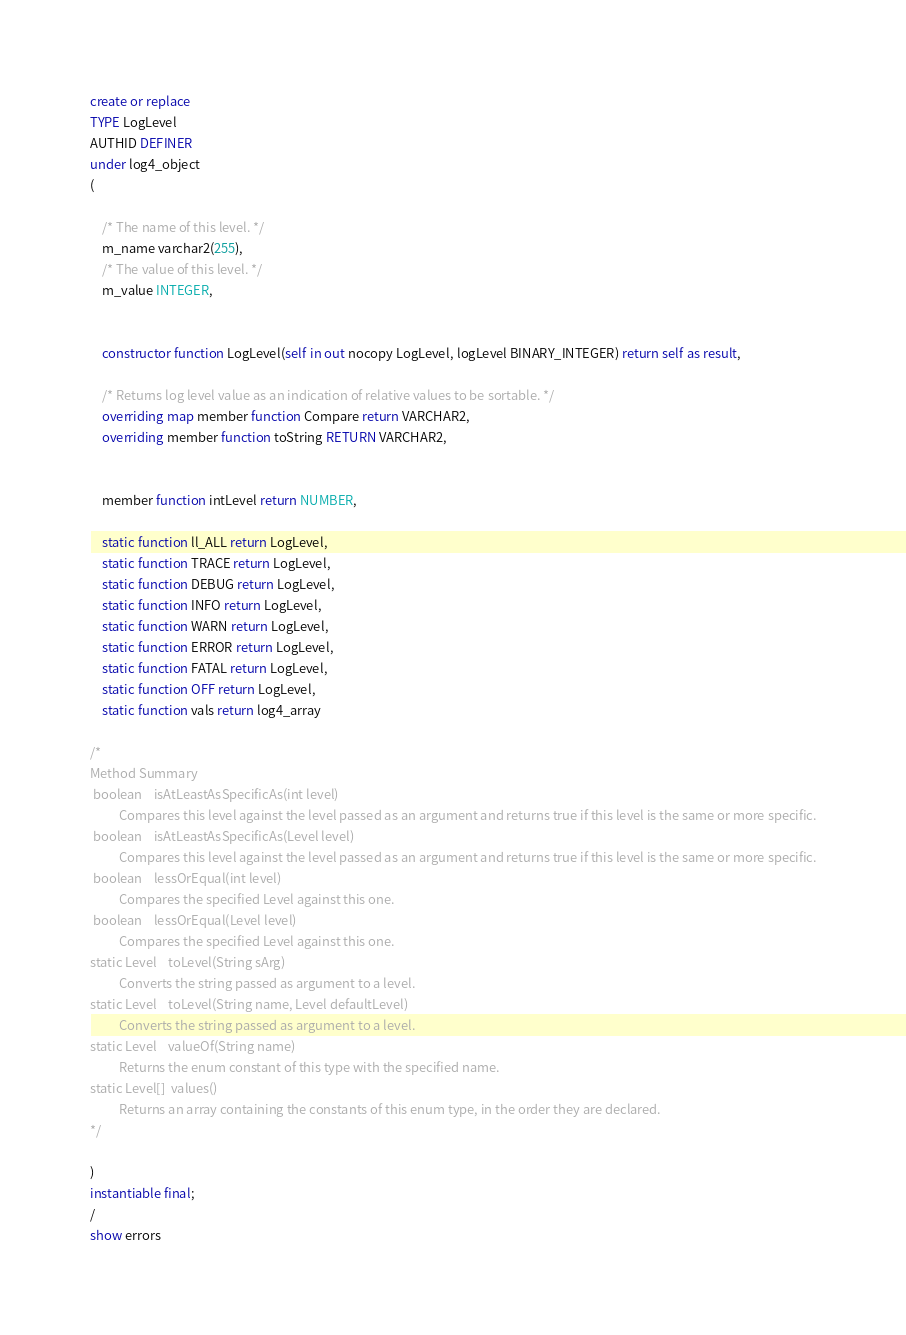<code> <loc_0><loc_0><loc_500><loc_500><_SQL_>create or replace
TYPE LogLevel 
AUTHID DEFINER
under log4_object
(

	/* The name of this level. */
	m_name varchar2(255),
	/* The value of this level. */
	m_value INTEGER,

	
	constructor function LogLevel(self in out nocopy LogLevel, logLevel BINARY_INTEGER) return self as result,

	/* Returns log level value as an indication of relative values to be sortable. */
	overriding map member function Compare return VARCHAR2,
	overriding member function toString RETURN VARCHAR2,


	member function intLevel return NUMBER,

	static function ll_ALL return LogLevel,
	static function TRACE return LogLevel,
	static function DEBUG return LogLevel,
	static function INFO return LogLevel,
	static function WARN return LogLevel,
	static function ERROR return LogLevel,
	static function FATAL return LogLevel,
	static function OFF return LogLevel,
	static function vals return log4_array

/*
Method Summary
 boolean	isAtLeastAsSpecificAs(int level) 
          Compares this level against the level passed as an argument and returns true if this level is the same or more specific.
 boolean	isAtLeastAsSpecificAs(Level level) 
          Compares this level against the level passed as an argument and returns true if this level is the same or more specific.
 boolean	lessOrEqual(int level) 
          Compares the specified Level against this one.
 boolean	lessOrEqual(Level level) 
          Compares the specified Level against this one.
static Level	toLevel(String sArg) 
          Converts the string passed as argument to a level.
static Level	toLevel(String name, Level defaultLevel) 
          Converts the string passed as argument to a level.
static Level	valueOf(String name) 
          Returns the enum constant of this type with the specified name.
static Level[]	values() 
          Returns an array containing the constants of this enum type, in the order they are declared.
*/

)
instantiable final;
/
show errors
</code> 